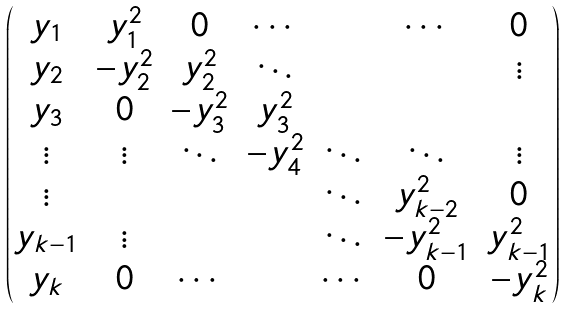<formula> <loc_0><loc_0><loc_500><loc_500>\begin{pmatrix} y _ { 1 } & y _ { 1 } ^ { 2 } & 0 & \cdots & & \cdots & 0 \\ y _ { 2 } & - y _ { 2 } ^ { 2 } & y _ { 2 } ^ { 2 } & \ddots & & & \vdots \\ y _ { 3 } & 0 & - y _ { 3 } ^ { 2 } & y _ { 3 } ^ { 2 } & & & \\ \vdots & \vdots & \ddots & - y _ { 4 } ^ { 2 } & \ddots & \ddots & \vdots \\ \vdots & & & & \ddots & y _ { k - 2 } ^ { 2 } & 0 \\ y _ { k - 1 } & \vdots & & & \ddots & - y _ { k - 1 } ^ { 2 } & y _ { k - 1 } ^ { 2 } \\ y _ { k } & 0 & \cdots & & \cdots & 0 & - y _ { k } ^ { 2 } \end{pmatrix}</formula> 